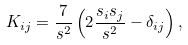Convert formula to latex. <formula><loc_0><loc_0><loc_500><loc_500>K _ { i j } = \frac { 7 } { s ^ { 2 } } \left ( 2 \frac { s _ { i } s _ { j } } { s ^ { 2 } } - \delta _ { i j } \right ) ,</formula> 